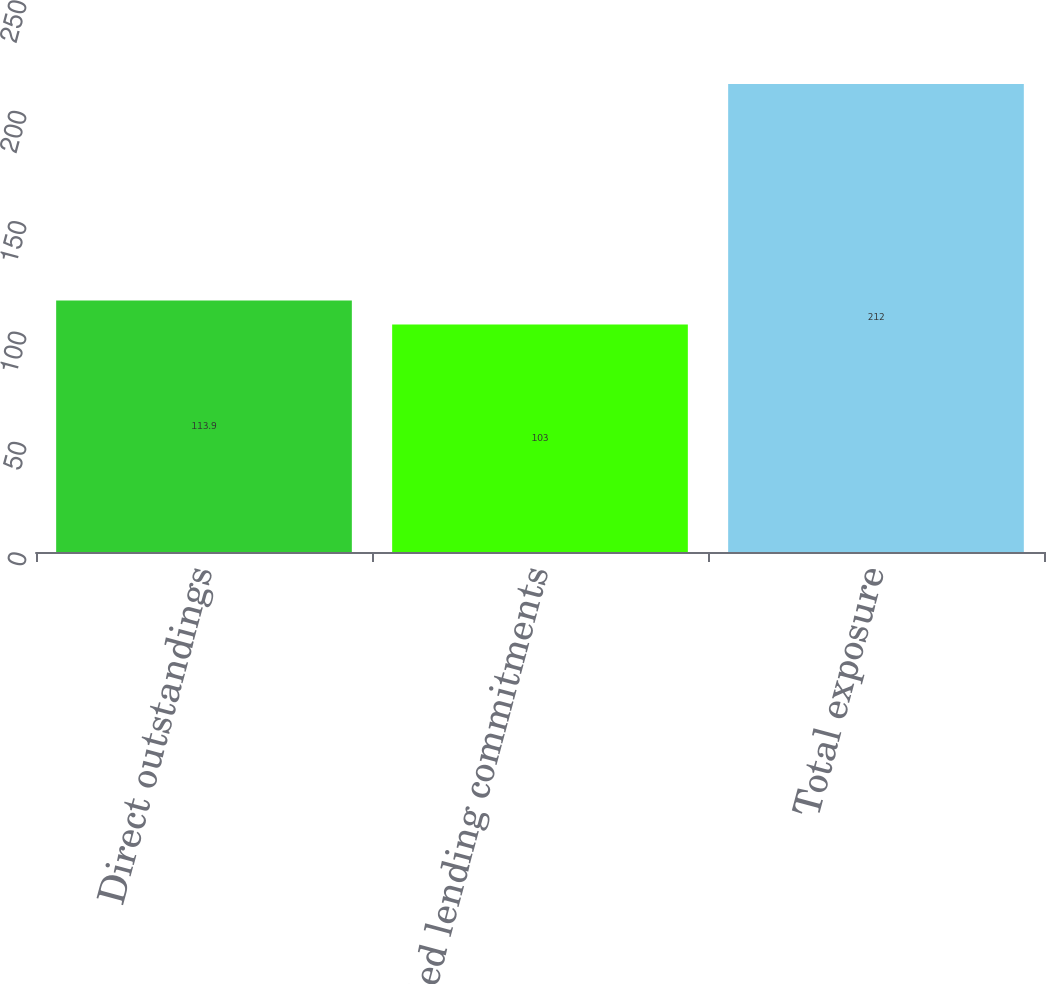Convert chart to OTSL. <chart><loc_0><loc_0><loc_500><loc_500><bar_chart><fcel>Direct outstandings<fcel>Unfunded lending commitments<fcel>Total exposure<nl><fcel>113.9<fcel>103<fcel>212<nl></chart> 